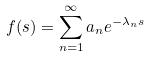<formula> <loc_0><loc_0><loc_500><loc_500>f ( s ) = \sum _ { n = 1 } ^ { \infty } a _ { n } e ^ { - \lambda _ { n } s }</formula> 